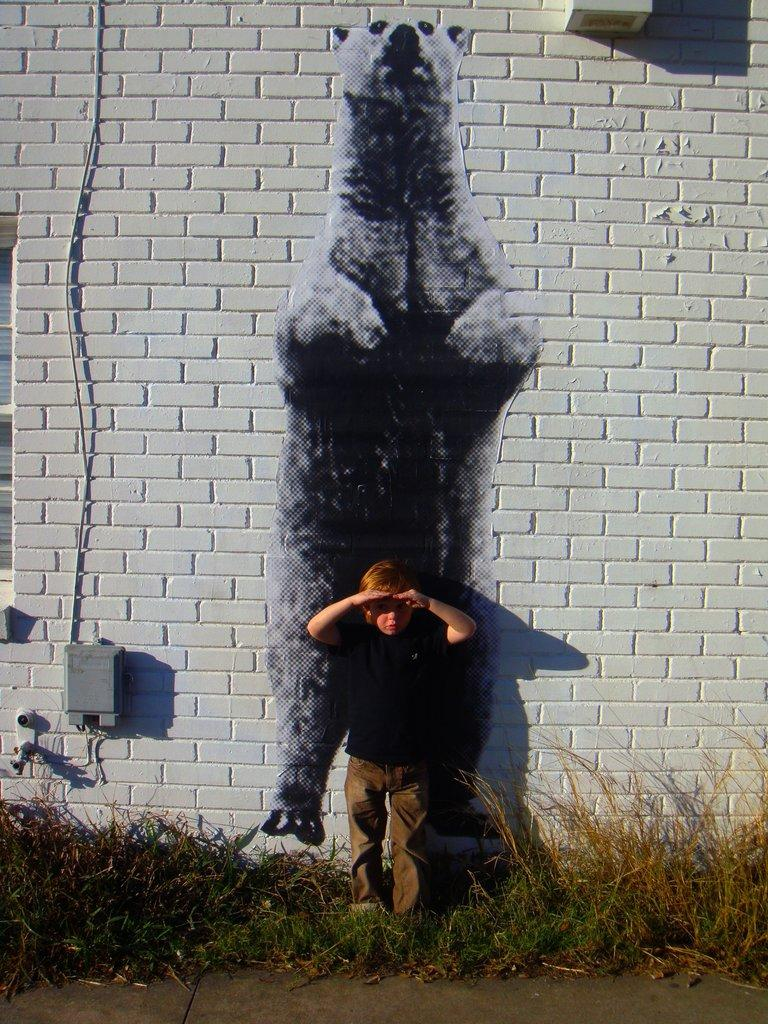What is the main subject of the image? There is a kid standing in the image. What can be seen beneath the kid's feet? The ground is visible in the image. What type of vegetation is present in the image? There is grass in the image. What is on the wall in the image? There is a wall with objects in the image, including a painting. Can you describe the painting on the wall? There is a painting on the wall in the image. What else can be seen in the image? There is a wire in the image. What type of property is being sold in the image? There is no indication of any property being sold in the image. Can you recite the verse written on the wall in the image? There is no verse written on the wall in the image; only a painting is present. 